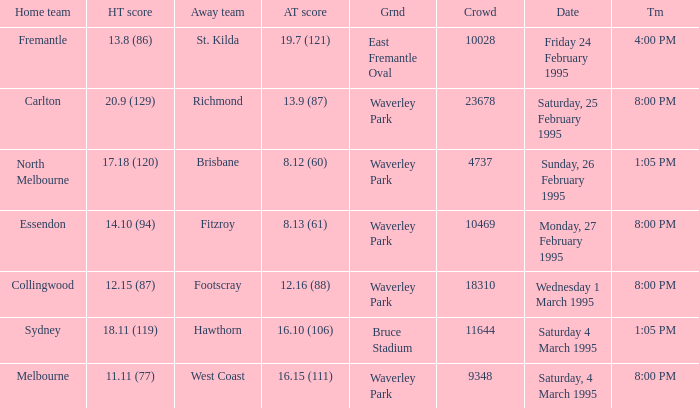Name the total number of grounds for essendon 1.0. 